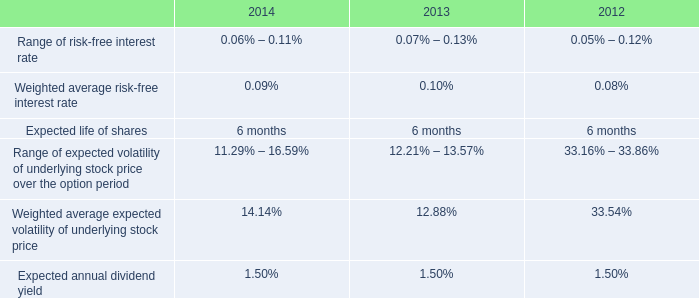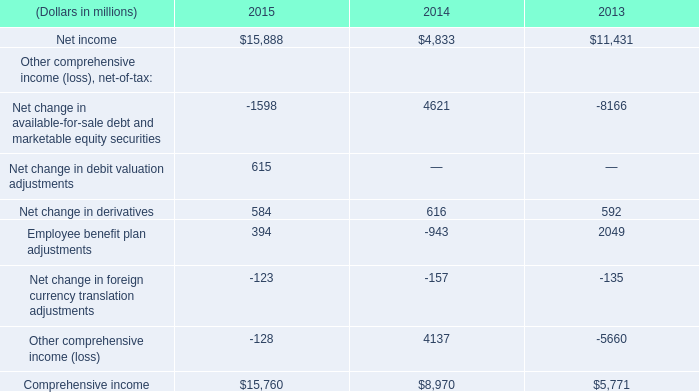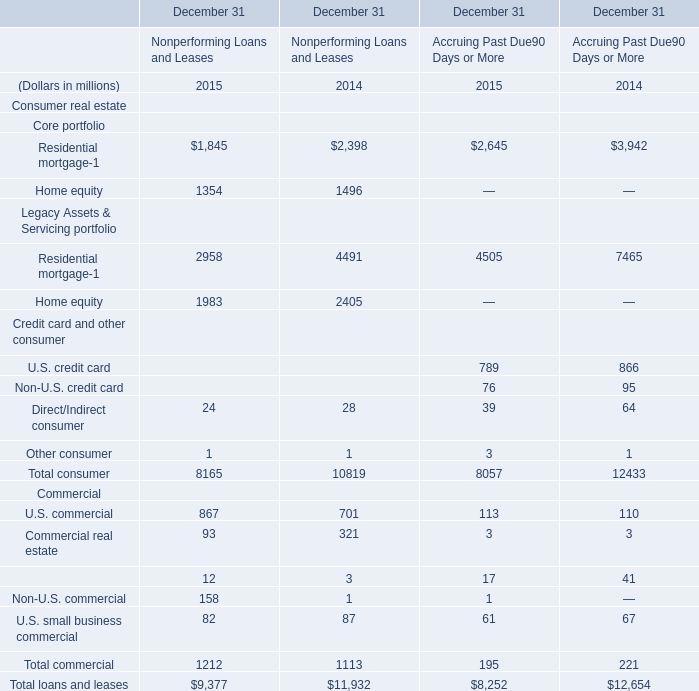What's the greatest value of consumer in non-performing loans and leases in 2015 ? 
Answer: 2958. 